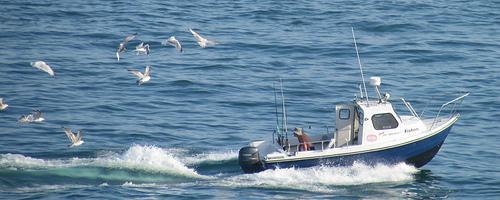How many boats?
Give a very brief answer. 1. 